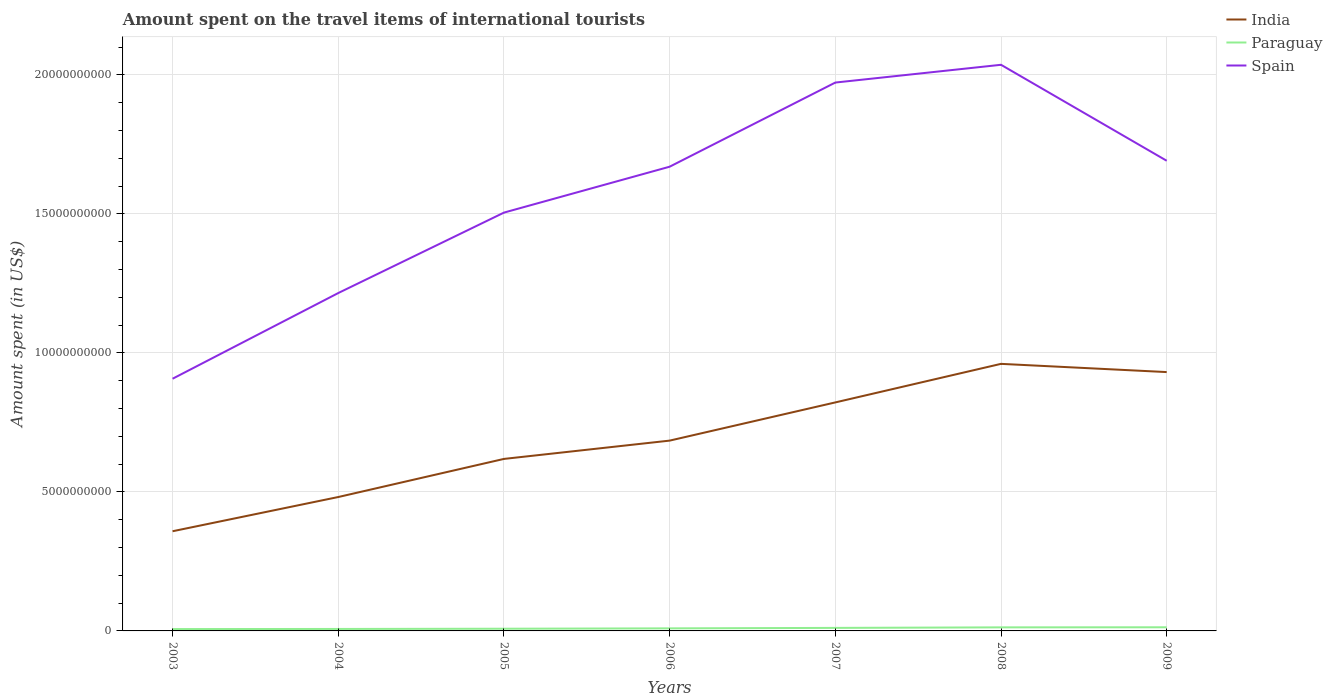How many different coloured lines are there?
Your answer should be compact. 3. Is the number of lines equal to the number of legend labels?
Offer a terse response. Yes. Across all years, what is the maximum amount spent on the travel items of international tourists in Spain?
Your answer should be very brief. 9.07e+09. What is the total amount spent on the travel items of international tourists in India in the graph?
Ensure brevity in your answer.  -1.39e+09. What is the difference between the highest and the second highest amount spent on the travel items of international tourists in India?
Offer a very short reply. 6.02e+09. What is the difference between the highest and the lowest amount spent on the travel items of international tourists in Paraguay?
Give a very brief answer. 3. Is the amount spent on the travel items of international tourists in Paraguay strictly greater than the amount spent on the travel items of international tourists in India over the years?
Offer a very short reply. Yes. How many lines are there?
Offer a very short reply. 3. Where does the legend appear in the graph?
Offer a very short reply. Top right. How many legend labels are there?
Make the answer very short. 3. How are the legend labels stacked?
Your answer should be compact. Vertical. What is the title of the graph?
Your answer should be compact. Amount spent on the travel items of international tourists. What is the label or title of the Y-axis?
Offer a terse response. Amount spent (in US$). What is the Amount spent (in US$) of India in 2003?
Your response must be concise. 3.58e+09. What is the Amount spent (in US$) of Paraguay in 2003?
Offer a terse response. 6.70e+07. What is the Amount spent (in US$) of Spain in 2003?
Offer a terse response. 9.07e+09. What is the Amount spent (in US$) in India in 2004?
Offer a very short reply. 4.82e+09. What is the Amount spent (in US$) of Paraguay in 2004?
Your response must be concise. 7.10e+07. What is the Amount spent (in US$) of Spain in 2004?
Provide a succinct answer. 1.22e+1. What is the Amount spent (in US$) of India in 2005?
Your response must be concise. 6.19e+09. What is the Amount spent (in US$) of Paraguay in 2005?
Give a very brief answer. 7.90e+07. What is the Amount spent (in US$) in Spain in 2005?
Provide a short and direct response. 1.50e+1. What is the Amount spent (in US$) in India in 2006?
Your response must be concise. 6.84e+09. What is the Amount spent (in US$) in Paraguay in 2006?
Give a very brief answer. 9.20e+07. What is the Amount spent (in US$) of Spain in 2006?
Your answer should be compact. 1.67e+1. What is the Amount spent (in US$) in India in 2007?
Ensure brevity in your answer.  8.22e+09. What is the Amount spent (in US$) in Paraguay in 2007?
Provide a short and direct response. 1.09e+08. What is the Amount spent (in US$) in Spain in 2007?
Your answer should be very brief. 1.97e+1. What is the Amount spent (in US$) of India in 2008?
Give a very brief answer. 9.61e+09. What is the Amount spent (in US$) of Paraguay in 2008?
Make the answer very short. 1.28e+08. What is the Amount spent (in US$) in Spain in 2008?
Keep it short and to the point. 2.04e+1. What is the Amount spent (in US$) of India in 2009?
Give a very brief answer. 9.31e+09. What is the Amount spent (in US$) in Paraguay in 2009?
Make the answer very short. 1.31e+08. What is the Amount spent (in US$) of Spain in 2009?
Keep it short and to the point. 1.69e+1. Across all years, what is the maximum Amount spent (in US$) in India?
Keep it short and to the point. 9.61e+09. Across all years, what is the maximum Amount spent (in US$) of Paraguay?
Your answer should be compact. 1.31e+08. Across all years, what is the maximum Amount spent (in US$) of Spain?
Make the answer very short. 2.04e+1. Across all years, what is the minimum Amount spent (in US$) of India?
Offer a very short reply. 3.58e+09. Across all years, what is the minimum Amount spent (in US$) in Paraguay?
Offer a very short reply. 6.70e+07. Across all years, what is the minimum Amount spent (in US$) of Spain?
Your answer should be compact. 9.07e+09. What is the total Amount spent (in US$) of India in the graph?
Your answer should be very brief. 4.86e+1. What is the total Amount spent (in US$) in Paraguay in the graph?
Your answer should be very brief. 6.77e+08. What is the total Amount spent (in US$) in Spain in the graph?
Provide a short and direct response. 1.10e+11. What is the difference between the Amount spent (in US$) in India in 2003 and that in 2004?
Make the answer very short. -1.23e+09. What is the difference between the Amount spent (in US$) of Spain in 2003 and that in 2004?
Provide a short and direct response. -3.08e+09. What is the difference between the Amount spent (in US$) in India in 2003 and that in 2005?
Your response must be concise. -2.60e+09. What is the difference between the Amount spent (in US$) of Paraguay in 2003 and that in 2005?
Your answer should be very brief. -1.20e+07. What is the difference between the Amount spent (in US$) of Spain in 2003 and that in 2005?
Your response must be concise. -5.98e+09. What is the difference between the Amount spent (in US$) of India in 2003 and that in 2006?
Your answer should be compact. -3.26e+09. What is the difference between the Amount spent (in US$) in Paraguay in 2003 and that in 2006?
Your answer should be compact. -2.50e+07. What is the difference between the Amount spent (in US$) in Spain in 2003 and that in 2006?
Keep it short and to the point. -7.63e+09. What is the difference between the Amount spent (in US$) of India in 2003 and that in 2007?
Make the answer very short. -4.63e+09. What is the difference between the Amount spent (in US$) of Paraguay in 2003 and that in 2007?
Provide a succinct answer. -4.20e+07. What is the difference between the Amount spent (in US$) in Spain in 2003 and that in 2007?
Offer a very short reply. -1.07e+1. What is the difference between the Amount spent (in US$) in India in 2003 and that in 2008?
Give a very brief answer. -6.02e+09. What is the difference between the Amount spent (in US$) in Paraguay in 2003 and that in 2008?
Offer a very short reply. -6.10e+07. What is the difference between the Amount spent (in US$) of Spain in 2003 and that in 2008?
Your response must be concise. -1.13e+1. What is the difference between the Amount spent (in US$) of India in 2003 and that in 2009?
Offer a terse response. -5.72e+09. What is the difference between the Amount spent (in US$) in Paraguay in 2003 and that in 2009?
Your answer should be compact. -6.40e+07. What is the difference between the Amount spent (in US$) in Spain in 2003 and that in 2009?
Ensure brevity in your answer.  -7.84e+09. What is the difference between the Amount spent (in US$) in India in 2004 and that in 2005?
Ensure brevity in your answer.  -1.37e+09. What is the difference between the Amount spent (in US$) in Paraguay in 2004 and that in 2005?
Make the answer very short. -8.00e+06. What is the difference between the Amount spent (in US$) in Spain in 2004 and that in 2005?
Your response must be concise. -2.89e+09. What is the difference between the Amount spent (in US$) in India in 2004 and that in 2006?
Ensure brevity in your answer.  -2.03e+09. What is the difference between the Amount spent (in US$) of Paraguay in 2004 and that in 2006?
Keep it short and to the point. -2.10e+07. What is the difference between the Amount spent (in US$) in Spain in 2004 and that in 2006?
Provide a succinct answer. -4.54e+09. What is the difference between the Amount spent (in US$) of India in 2004 and that in 2007?
Offer a terse response. -3.40e+09. What is the difference between the Amount spent (in US$) of Paraguay in 2004 and that in 2007?
Your answer should be very brief. -3.80e+07. What is the difference between the Amount spent (in US$) of Spain in 2004 and that in 2007?
Ensure brevity in your answer.  -7.57e+09. What is the difference between the Amount spent (in US$) of India in 2004 and that in 2008?
Your answer should be very brief. -4.79e+09. What is the difference between the Amount spent (in US$) in Paraguay in 2004 and that in 2008?
Provide a succinct answer. -5.70e+07. What is the difference between the Amount spent (in US$) in Spain in 2004 and that in 2008?
Your answer should be compact. -8.21e+09. What is the difference between the Amount spent (in US$) in India in 2004 and that in 2009?
Ensure brevity in your answer.  -4.49e+09. What is the difference between the Amount spent (in US$) of Paraguay in 2004 and that in 2009?
Provide a short and direct response. -6.00e+07. What is the difference between the Amount spent (in US$) in Spain in 2004 and that in 2009?
Your answer should be very brief. -4.76e+09. What is the difference between the Amount spent (in US$) of India in 2005 and that in 2006?
Provide a succinct answer. -6.58e+08. What is the difference between the Amount spent (in US$) of Paraguay in 2005 and that in 2006?
Provide a succinct answer. -1.30e+07. What is the difference between the Amount spent (in US$) in Spain in 2005 and that in 2006?
Provide a short and direct response. -1.65e+09. What is the difference between the Amount spent (in US$) in India in 2005 and that in 2007?
Provide a succinct answer. -2.03e+09. What is the difference between the Amount spent (in US$) of Paraguay in 2005 and that in 2007?
Give a very brief answer. -3.00e+07. What is the difference between the Amount spent (in US$) of Spain in 2005 and that in 2007?
Provide a short and direct response. -4.68e+09. What is the difference between the Amount spent (in US$) in India in 2005 and that in 2008?
Provide a short and direct response. -3.42e+09. What is the difference between the Amount spent (in US$) of Paraguay in 2005 and that in 2008?
Offer a very short reply. -4.90e+07. What is the difference between the Amount spent (in US$) of Spain in 2005 and that in 2008?
Give a very brief answer. -5.32e+09. What is the difference between the Amount spent (in US$) in India in 2005 and that in 2009?
Give a very brief answer. -3.12e+09. What is the difference between the Amount spent (in US$) in Paraguay in 2005 and that in 2009?
Provide a short and direct response. -5.20e+07. What is the difference between the Amount spent (in US$) in Spain in 2005 and that in 2009?
Make the answer very short. -1.86e+09. What is the difference between the Amount spent (in US$) of India in 2006 and that in 2007?
Ensure brevity in your answer.  -1.37e+09. What is the difference between the Amount spent (in US$) of Paraguay in 2006 and that in 2007?
Your answer should be compact. -1.70e+07. What is the difference between the Amount spent (in US$) of Spain in 2006 and that in 2007?
Offer a very short reply. -3.03e+09. What is the difference between the Amount spent (in US$) of India in 2006 and that in 2008?
Your answer should be very brief. -2.76e+09. What is the difference between the Amount spent (in US$) in Paraguay in 2006 and that in 2008?
Offer a terse response. -3.60e+07. What is the difference between the Amount spent (in US$) in Spain in 2006 and that in 2008?
Your answer should be compact. -3.67e+09. What is the difference between the Amount spent (in US$) of India in 2006 and that in 2009?
Offer a very short reply. -2.46e+09. What is the difference between the Amount spent (in US$) in Paraguay in 2006 and that in 2009?
Make the answer very short. -3.90e+07. What is the difference between the Amount spent (in US$) in Spain in 2006 and that in 2009?
Your answer should be compact. -2.14e+08. What is the difference between the Amount spent (in US$) of India in 2007 and that in 2008?
Provide a short and direct response. -1.39e+09. What is the difference between the Amount spent (in US$) of Paraguay in 2007 and that in 2008?
Provide a succinct answer. -1.90e+07. What is the difference between the Amount spent (in US$) in Spain in 2007 and that in 2008?
Provide a short and direct response. -6.39e+08. What is the difference between the Amount spent (in US$) of India in 2007 and that in 2009?
Give a very brief answer. -1.09e+09. What is the difference between the Amount spent (in US$) of Paraguay in 2007 and that in 2009?
Offer a very short reply. -2.20e+07. What is the difference between the Amount spent (in US$) of Spain in 2007 and that in 2009?
Your response must be concise. 2.81e+09. What is the difference between the Amount spent (in US$) in India in 2008 and that in 2009?
Provide a succinct answer. 2.96e+08. What is the difference between the Amount spent (in US$) of Paraguay in 2008 and that in 2009?
Give a very brief answer. -3.00e+06. What is the difference between the Amount spent (in US$) of Spain in 2008 and that in 2009?
Your response must be concise. 3.45e+09. What is the difference between the Amount spent (in US$) of India in 2003 and the Amount spent (in US$) of Paraguay in 2004?
Offer a very short reply. 3.51e+09. What is the difference between the Amount spent (in US$) in India in 2003 and the Amount spent (in US$) in Spain in 2004?
Your answer should be compact. -8.57e+09. What is the difference between the Amount spent (in US$) of Paraguay in 2003 and the Amount spent (in US$) of Spain in 2004?
Give a very brief answer. -1.21e+1. What is the difference between the Amount spent (in US$) of India in 2003 and the Amount spent (in US$) of Paraguay in 2005?
Give a very brief answer. 3.51e+09. What is the difference between the Amount spent (in US$) of India in 2003 and the Amount spent (in US$) of Spain in 2005?
Provide a short and direct response. -1.15e+1. What is the difference between the Amount spent (in US$) of Paraguay in 2003 and the Amount spent (in US$) of Spain in 2005?
Offer a very short reply. -1.50e+1. What is the difference between the Amount spent (in US$) in India in 2003 and the Amount spent (in US$) in Paraguay in 2006?
Offer a very short reply. 3.49e+09. What is the difference between the Amount spent (in US$) in India in 2003 and the Amount spent (in US$) in Spain in 2006?
Give a very brief answer. -1.31e+1. What is the difference between the Amount spent (in US$) of Paraguay in 2003 and the Amount spent (in US$) of Spain in 2006?
Your response must be concise. -1.66e+1. What is the difference between the Amount spent (in US$) in India in 2003 and the Amount spent (in US$) in Paraguay in 2007?
Ensure brevity in your answer.  3.48e+09. What is the difference between the Amount spent (in US$) of India in 2003 and the Amount spent (in US$) of Spain in 2007?
Your answer should be very brief. -1.61e+1. What is the difference between the Amount spent (in US$) in Paraguay in 2003 and the Amount spent (in US$) in Spain in 2007?
Offer a terse response. -1.97e+1. What is the difference between the Amount spent (in US$) of India in 2003 and the Amount spent (in US$) of Paraguay in 2008?
Offer a terse response. 3.46e+09. What is the difference between the Amount spent (in US$) in India in 2003 and the Amount spent (in US$) in Spain in 2008?
Provide a succinct answer. -1.68e+1. What is the difference between the Amount spent (in US$) in Paraguay in 2003 and the Amount spent (in US$) in Spain in 2008?
Give a very brief answer. -2.03e+1. What is the difference between the Amount spent (in US$) in India in 2003 and the Amount spent (in US$) in Paraguay in 2009?
Give a very brief answer. 3.45e+09. What is the difference between the Amount spent (in US$) of India in 2003 and the Amount spent (in US$) of Spain in 2009?
Your response must be concise. -1.33e+1. What is the difference between the Amount spent (in US$) in Paraguay in 2003 and the Amount spent (in US$) in Spain in 2009?
Offer a terse response. -1.68e+1. What is the difference between the Amount spent (in US$) of India in 2004 and the Amount spent (in US$) of Paraguay in 2005?
Keep it short and to the point. 4.74e+09. What is the difference between the Amount spent (in US$) of India in 2004 and the Amount spent (in US$) of Spain in 2005?
Make the answer very short. -1.02e+1. What is the difference between the Amount spent (in US$) of Paraguay in 2004 and the Amount spent (in US$) of Spain in 2005?
Keep it short and to the point. -1.50e+1. What is the difference between the Amount spent (in US$) of India in 2004 and the Amount spent (in US$) of Paraguay in 2006?
Keep it short and to the point. 4.72e+09. What is the difference between the Amount spent (in US$) in India in 2004 and the Amount spent (in US$) in Spain in 2006?
Give a very brief answer. -1.19e+1. What is the difference between the Amount spent (in US$) in Paraguay in 2004 and the Amount spent (in US$) in Spain in 2006?
Your answer should be compact. -1.66e+1. What is the difference between the Amount spent (in US$) in India in 2004 and the Amount spent (in US$) in Paraguay in 2007?
Your response must be concise. 4.71e+09. What is the difference between the Amount spent (in US$) in India in 2004 and the Amount spent (in US$) in Spain in 2007?
Your response must be concise. -1.49e+1. What is the difference between the Amount spent (in US$) of Paraguay in 2004 and the Amount spent (in US$) of Spain in 2007?
Keep it short and to the point. -1.97e+1. What is the difference between the Amount spent (in US$) in India in 2004 and the Amount spent (in US$) in Paraguay in 2008?
Provide a succinct answer. 4.69e+09. What is the difference between the Amount spent (in US$) of India in 2004 and the Amount spent (in US$) of Spain in 2008?
Give a very brief answer. -1.55e+1. What is the difference between the Amount spent (in US$) of Paraguay in 2004 and the Amount spent (in US$) of Spain in 2008?
Your answer should be very brief. -2.03e+1. What is the difference between the Amount spent (in US$) in India in 2004 and the Amount spent (in US$) in Paraguay in 2009?
Ensure brevity in your answer.  4.68e+09. What is the difference between the Amount spent (in US$) of India in 2004 and the Amount spent (in US$) of Spain in 2009?
Your answer should be very brief. -1.21e+1. What is the difference between the Amount spent (in US$) in Paraguay in 2004 and the Amount spent (in US$) in Spain in 2009?
Offer a terse response. -1.68e+1. What is the difference between the Amount spent (in US$) in India in 2005 and the Amount spent (in US$) in Paraguay in 2006?
Your answer should be very brief. 6.10e+09. What is the difference between the Amount spent (in US$) of India in 2005 and the Amount spent (in US$) of Spain in 2006?
Your response must be concise. -1.05e+1. What is the difference between the Amount spent (in US$) in Paraguay in 2005 and the Amount spent (in US$) in Spain in 2006?
Offer a very short reply. -1.66e+1. What is the difference between the Amount spent (in US$) in India in 2005 and the Amount spent (in US$) in Paraguay in 2007?
Your answer should be compact. 6.08e+09. What is the difference between the Amount spent (in US$) of India in 2005 and the Amount spent (in US$) of Spain in 2007?
Offer a terse response. -1.35e+1. What is the difference between the Amount spent (in US$) of Paraguay in 2005 and the Amount spent (in US$) of Spain in 2007?
Ensure brevity in your answer.  -1.96e+1. What is the difference between the Amount spent (in US$) in India in 2005 and the Amount spent (in US$) in Paraguay in 2008?
Provide a short and direct response. 6.06e+09. What is the difference between the Amount spent (in US$) in India in 2005 and the Amount spent (in US$) in Spain in 2008?
Your answer should be very brief. -1.42e+1. What is the difference between the Amount spent (in US$) of Paraguay in 2005 and the Amount spent (in US$) of Spain in 2008?
Keep it short and to the point. -2.03e+1. What is the difference between the Amount spent (in US$) in India in 2005 and the Amount spent (in US$) in Paraguay in 2009?
Your response must be concise. 6.06e+09. What is the difference between the Amount spent (in US$) in India in 2005 and the Amount spent (in US$) in Spain in 2009?
Offer a terse response. -1.07e+1. What is the difference between the Amount spent (in US$) in Paraguay in 2005 and the Amount spent (in US$) in Spain in 2009?
Your answer should be very brief. -1.68e+1. What is the difference between the Amount spent (in US$) in India in 2006 and the Amount spent (in US$) in Paraguay in 2007?
Your answer should be very brief. 6.74e+09. What is the difference between the Amount spent (in US$) of India in 2006 and the Amount spent (in US$) of Spain in 2007?
Offer a terse response. -1.29e+1. What is the difference between the Amount spent (in US$) of Paraguay in 2006 and the Amount spent (in US$) of Spain in 2007?
Your answer should be compact. -1.96e+1. What is the difference between the Amount spent (in US$) in India in 2006 and the Amount spent (in US$) in Paraguay in 2008?
Your answer should be compact. 6.72e+09. What is the difference between the Amount spent (in US$) of India in 2006 and the Amount spent (in US$) of Spain in 2008?
Offer a terse response. -1.35e+1. What is the difference between the Amount spent (in US$) of Paraguay in 2006 and the Amount spent (in US$) of Spain in 2008?
Make the answer very short. -2.03e+1. What is the difference between the Amount spent (in US$) in India in 2006 and the Amount spent (in US$) in Paraguay in 2009?
Provide a succinct answer. 6.71e+09. What is the difference between the Amount spent (in US$) in India in 2006 and the Amount spent (in US$) in Spain in 2009?
Your answer should be compact. -1.01e+1. What is the difference between the Amount spent (in US$) of Paraguay in 2006 and the Amount spent (in US$) of Spain in 2009?
Offer a very short reply. -1.68e+1. What is the difference between the Amount spent (in US$) of India in 2007 and the Amount spent (in US$) of Paraguay in 2008?
Ensure brevity in your answer.  8.09e+09. What is the difference between the Amount spent (in US$) in India in 2007 and the Amount spent (in US$) in Spain in 2008?
Your answer should be very brief. -1.21e+1. What is the difference between the Amount spent (in US$) in Paraguay in 2007 and the Amount spent (in US$) in Spain in 2008?
Make the answer very short. -2.03e+1. What is the difference between the Amount spent (in US$) in India in 2007 and the Amount spent (in US$) in Paraguay in 2009?
Your response must be concise. 8.09e+09. What is the difference between the Amount spent (in US$) in India in 2007 and the Amount spent (in US$) in Spain in 2009?
Make the answer very short. -8.69e+09. What is the difference between the Amount spent (in US$) of Paraguay in 2007 and the Amount spent (in US$) of Spain in 2009?
Offer a very short reply. -1.68e+1. What is the difference between the Amount spent (in US$) of India in 2008 and the Amount spent (in US$) of Paraguay in 2009?
Give a very brief answer. 9.48e+09. What is the difference between the Amount spent (in US$) in India in 2008 and the Amount spent (in US$) in Spain in 2009?
Provide a succinct answer. -7.30e+09. What is the difference between the Amount spent (in US$) of Paraguay in 2008 and the Amount spent (in US$) of Spain in 2009?
Offer a terse response. -1.68e+1. What is the average Amount spent (in US$) of India per year?
Offer a terse response. 6.94e+09. What is the average Amount spent (in US$) in Paraguay per year?
Make the answer very short. 9.67e+07. What is the average Amount spent (in US$) in Spain per year?
Provide a short and direct response. 1.57e+1. In the year 2003, what is the difference between the Amount spent (in US$) of India and Amount spent (in US$) of Paraguay?
Offer a very short reply. 3.52e+09. In the year 2003, what is the difference between the Amount spent (in US$) of India and Amount spent (in US$) of Spain?
Offer a terse response. -5.49e+09. In the year 2003, what is the difference between the Amount spent (in US$) of Paraguay and Amount spent (in US$) of Spain?
Provide a succinct answer. -9.00e+09. In the year 2004, what is the difference between the Amount spent (in US$) in India and Amount spent (in US$) in Paraguay?
Provide a succinct answer. 4.74e+09. In the year 2004, what is the difference between the Amount spent (in US$) in India and Amount spent (in US$) in Spain?
Give a very brief answer. -7.34e+09. In the year 2004, what is the difference between the Amount spent (in US$) of Paraguay and Amount spent (in US$) of Spain?
Provide a succinct answer. -1.21e+1. In the year 2005, what is the difference between the Amount spent (in US$) in India and Amount spent (in US$) in Paraguay?
Make the answer very short. 6.11e+09. In the year 2005, what is the difference between the Amount spent (in US$) in India and Amount spent (in US$) in Spain?
Your answer should be compact. -8.86e+09. In the year 2005, what is the difference between the Amount spent (in US$) of Paraguay and Amount spent (in US$) of Spain?
Offer a terse response. -1.50e+1. In the year 2006, what is the difference between the Amount spent (in US$) of India and Amount spent (in US$) of Paraguay?
Make the answer very short. 6.75e+09. In the year 2006, what is the difference between the Amount spent (in US$) in India and Amount spent (in US$) in Spain?
Keep it short and to the point. -9.85e+09. In the year 2006, what is the difference between the Amount spent (in US$) of Paraguay and Amount spent (in US$) of Spain?
Provide a short and direct response. -1.66e+1. In the year 2007, what is the difference between the Amount spent (in US$) in India and Amount spent (in US$) in Paraguay?
Offer a very short reply. 8.11e+09. In the year 2007, what is the difference between the Amount spent (in US$) in India and Amount spent (in US$) in Spain?
Provide a succinct answer. -1.15e+1. In the year 2007, what is the difference between the Amount spent (in US$) in Paraguay and Amount spent (in US$) in Spain?
Make the answer very short. -1.96e+1. In the year 2008, what is the difference between the Amount spent (in US$) in India and Amount spent (in US$) in Paraguay?
Provide a short and direct response. 9.48e+09. In the year 2008, what is the difference between the Amount spent (in US$) of India and Amount spent (in US$) of Spain?
Make the answer very short. -1.08e+1. In the year 2008, what is the difference between the Amount spent (in US$) in Paraguay and Amount spent (in US$) in Spain?
Give a very brief answer. -2.02e+1. In the year 2009, what is the difference between the Amount spent (in US$) in India and Amount spent (in US$) in Paraguay?
Your answer should be compact. 9.18e+09. In the year 2009, what is the difference between the Amount spent (in US$) in India and Amount spent (in US$) in Spain?
Offer a terse response. -7.60e+09. In the year 2009, what is the difference between the Amount spent (in US$) in Paraguay and Amount spent (in US$) in Spain?
Your answer should be very brief. -1.68e+1. What is the ratio of the Amount spent (in US$) of India in 2003 to that in 2004?
Give a very brief answer. 0.74. What is the ratio of the Amount spent (in US$) in Paraguay in 2003 to that in 2004?
Offer a very short reply. 0.94. What is the ratio of the Amount spent (in US$) of Spain in 2003 to that in 2004?
Your answer should be very brief. 0.75. What is the ratio of the Amount spent (in US$) in India in 2003 to that in 2005?
Keep it short and to the point. 0.58. What is the ratio of the Amount spent (in US$) of Paraguay in 2003 to that in 2005?
Your answer should be compact. 0.85. What is the ratio of the Amount spent (in US$) of Spain in 2003 to that in 2005?
Provide a short and direct response. 0.6. What is the ratio of the Amount spent (in US$) in India in 2003 to that in 2006?
Your answer should be very brief. 0.52. What is the ratio of the Amount spent (in US$) of Paraguay in 2003 to that in 2006?
Make the answer very short. 0.73. What is the ratio of the Amount spent (in US$) of Spain in 2003 to that in 2006?
Make the answer very short. 0.54. What is the ratio of the Amount spent (in US$) in India in 2003 to that in 2007?
Provide a short and direct response. 0.44. What is the ratio of the Amount spent (in US$) of Paraguay in 2003 to that in 2007?
Ensure brevity in your answer.  0.61. What is the ratio of the Amount spent (in US$) of Spain in 2003 to that in 2007?
Offer a very short reply. 0.46. What is the ratio of the Amount spent (in US$) of India in 2003 to that in 2008?
Your answer should be very brief. 0.37. What is the ratio of the Amount spent (in US$) in Paraguay in 2003 to that in 2008?
Your answer should be very brief. 0.52. What is the ratio of the Amount spent (in US$) of Spain in 2003 to that in 2008?
Keep it short and to the point. 0.45. What is the ratio of the Amount spent (in US$) in India in 2003 to that in 2009?
Offer a very short reply. 0.39. What is the ratio of the Amount spent (in US$) in Paraguay in 2003 to that in 2009?
Provide a short and direct response. 0.51. What is the ratio of the Amount spent (in US$) of Spain in 2003 to that in 2009?
Ensure brevity in your answer.  0.54. What is the ratio of the Amount spent (in US$) in India in 2004 to that in 2005?
Provide a succinct answer. 0.78. What is the ratio of the Amount spent (in US$) in Paraguay in 2004 to that in 2005?
Keep it short and to the point. 0.9. What is the ratio of the Amount spent (in US$) of Spain in 2004 to that in 2005?
Ensure brevity in your answer.  0.81. What is the ratio of the Amount spent (in US$) in India in 2004 to that in 2006?
Your answer should be very brief. 0.7. What is the ratio of the Amount spent (in US$) in Paraguay in 2004 to that in 2006?
Provide a succinct answer. 0.77. What is the ratio of the Amount spent (in US$) of Spain in 2004 to that in 2006?
Provide a short and direct response. 0.73. What is the ratio of the Amount spent (in US$) of India in 2004 to that in 2007?
Your answer should be very brief. 0.59. What is the ratio of the Amount spent (in US$) of Paraguay in 2004 to that in 2007?
Your answer should be compact. 0.65. What is the ratio of the Amount spent (in US$) of Spain in 2004 to that in 2007?
Ensure brevity in your answer.  0.62. What is the ratio of the Amount spent (in US$) of India in 2004 to that in 2008?
Offer a very short reply. 0.5. What is the ratio of the Amount spent (in US$) of Paraguay in 2004 to that in 2008?
Provide a short and direct response. 0.55. What is the ratio of the Amount spent (in US$) of Spain in 2004 to that in 2008?
Offer a terse response. 0.6. What is the ratio of the Amount spent (in US$) of India in 2004 to that in 2009?
Your answer should be compact. 0.52. What is the ratio of the Amount spent (in US$) of Paraguay in 2004 to that in 2009?
Keep it short and to the point. 0.54. What is the ratio of the Amount spent (in US$) in Spain in 2004 to that in 2009?
Your answer should be compact. 0.72. What is the ratio of the Amount spent (in US$) in India in 2005 to that in 2006?
Give a very brief answer. 0.9. What is the ratio of the Amount spent (in US$) in Paraguay in 2005 to that in 2006?
Give a very brief answer. 0.86. What is the ratio of the Amount spent (in US$) in Spain in 2005 to that in 2006?
Ensure brevity in your answer.  0.9. What is the ratio of the Amount spent (in US$) in India in 2005 to that in 2007?
Your answer should be compact. 0.75. What is the ratio of the Amount spent (in US$) of Paraguay in 2005 to that in 2007?
Your response must be concise. 0.72. What is the ratio of the Amount spent (in US$) in Spain in 2005 to that in 2007?
Your response must be concise. 0.76. What is the ratio of the Amount spent (in US$) of India in 2005 to that in 2008?
Make the answer very short. 0.64. What is the ratio of the Amount spent (in US$) of Paraguay in 2005 to that in 2008?
Provide a short and direct response. 0.62. What is the ratio of the Amount spent (in US$) of Spain in 2005 to that in 2008?
Your response must be concise. 0.74. What is the ratio of the Amount spent (in US$) in India in 2005 to that in 2009?
Offer a terse response. 0.66. What is the ratio of the Amount spent (in US$) in Paraguay in 2005 to that in 2009?
Your response must be concise. 0.6. What is the ratio of the Amount spent (in US$) of Spain in 2005 to that in 2009?
Provide a succinct answer. 0.89. What is the ratio of the Amount spent (in US$) in India in 2006 to that in 2007?
Your response must be concise. 0.83. What is the ratio of the Amount spent (in US$) in Paraguay in 2006 to that in 2007?
Your answer should be compact. 0.84. What is the ratio of the Amount spent (in US$) of Spain in 2006 to that in 2007?
Keep it short and to the point. 0.85. What is the ratio of the Amount spent (in US$) in India in 2006 to that in 2008?
Make the answer very short. 0.71. What is the ratio of the Amount spent (in US$) of Paraguay in 2006 to that in 2008?
Give a very brief answer. 0.72. What is the ratio of the Amount spent (in US$) of Spain in 2006 to that in 2008?
Offer a very short reply. 0.82. What is the ratio of the Amount spent (in US$) of India in 2006 to that in 2009?
Make the answer very short. 0.74. What is the ratio of the Amount spent (in US$) in Paraguay in 2006 to that in 2009?
Provide a succinct answer. 0.7. What is the ratio of the Amount spent (in US$) of Spain in 2006 to that in 2009?
Your answer should be compact. 0.99. What is the ratio of the Amount spent (in US$) of India in 2007 to that in 2008?
Provide a succinct answer. 0.86. What is the ratio of the Amount spent (in US$) in Paraguay in 2007 to that in 2008?
Keep it short and to the point. 0.85. What is the ratio of the Amount spent (in US$) of Spain in 2007 to that in 2008?
Provide a succinct answer. 0.97. What is the ratio of the Amount spent (in US$) of India in 2007 to that in 2009?
Keep it short and to the point. 0.88. What is the ratio of the Amount spent (in US$) in Paraguay in 2007 to that in 2009?
Your response must be concise. 0.83. What is the ratio of the Amount spent (in US$) of Spain in 2007 to that in 2009?
Your answer should be compact. 1.17. What is the ratio of the Amount spent (in US$) of India in 2008 to that in 2009?
Provide a short and direct response. 1.03. What is the ratio of the Amount spent (in US$) in Paraguay in 2008 to that in 2009?
Keep it short and to the point. 0.98. What is the ratio of the Amount spent (in US$) in Spain in 2008 to that in 2009?
Keep it short and to the point. 1.2. What is the difference between the highest and the second highest Amount spent (in US$) of India?
Offer a very short reply. 2.96e+08. What is the difference between the highest and the second highest Amount spent (in US$) of Spain?
Make the answer very short. 6.39e+08. What is the difference between the highest and the lowest Amount spent (in US$) in India?
Offer a very short reply. 6.02e+09. What is the difference between the highest and the lowest Amount spent (in US$) in Paraguay?
Your answer should be very brief. 6.40e+07. What is the difference between the highest and the lowest Amount spent (in US$) of Spain?
Offer a terse response. 1.13e+1. 